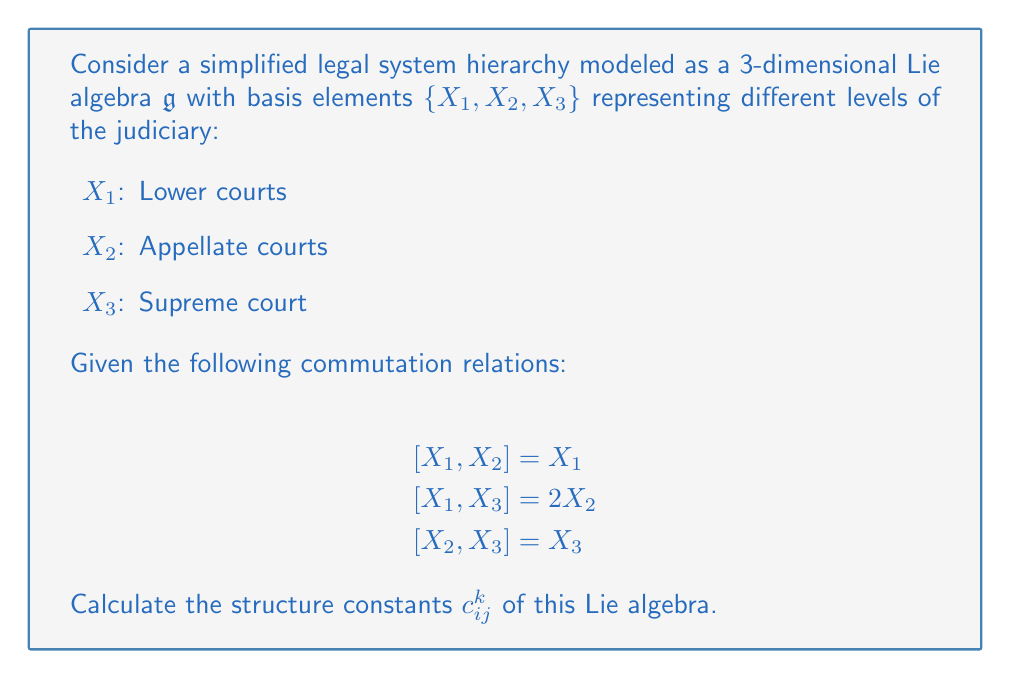What is the answer to this math problem? To calculate the structure constants of the given Lie algebra, we need to express each commutation relation in terms of the structure constants. The general form of a commutation relation is:

$$[X_i, X_j] = \sum_{k=1}^3 c_{ij}^k X_k$$

where $c_{ij}^k$ are the structure constants.

Let's analyze each commutation relation:

1) $[X_1, X_2] = X_1$
   This implies: $c_{12}^1 = 1$, $c_{12}^2 = 0$, $c_{12}^3 = 0$

2) $[X_1, X_3] = 2X_2$
   This implies: $c_{13}^1 = 0$, $c_{13}^2 = 2$, $c_{13}^3 = 0$

3) $[X_2, X_3] = X_3$
   This implies: $c_{23}^1 = 0$, $c_{23}^2 = 0$, $c_{23}^3 = 1$

Note that the structure constants are antisymmetric in the lower indices, so:

$c_{ji}^k = -c_{ij}^k$

This gives us:

$c_{21}^k = -c_{12}^k$, $c_{31}^k = -c_{13}^k$, $c_{32}^k = -c_{23}^k$

All other structure constants not mentioned above are zero.

The complete set of non-zero structure constants is:

$c_{12}^1 = 1$, $c_{21}^1 = -1$
$c_{13}^2 = 2$, $c_{31}^2 = -2$
$c_{23}^3 = 1$, $c_{32}^3 = -1$
Answer: The non-zero structure constants are:
$$c_{12}^1 = 1, c_{21}^1 = -1, c_{13}^2 = 2, c_{31}^2 = -2, c_{23}^3 = 1, c_{32}^3 = -1$$
All other $c_{ij}^k = 0$. 